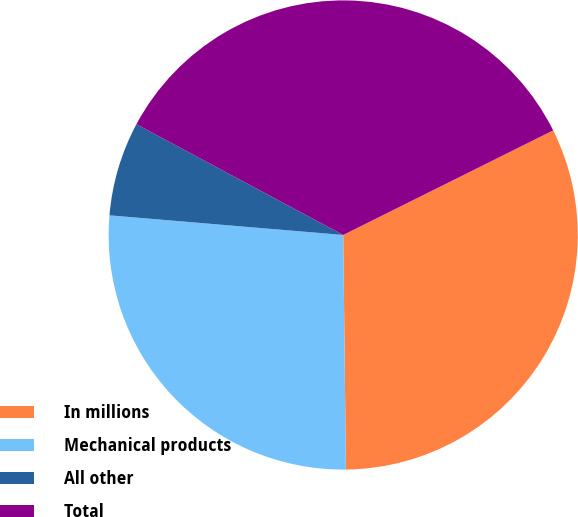<chart> <loc_0><loc_0><loc_500><loc_500><pie_chart><fcel>In millions<fcel>Mechanical products<fcel>All other<fcel>Total<nl><fcel>32.17%<fcel>26.52%<fcel>6.49%<fcel>34.82%<nl></chart> 